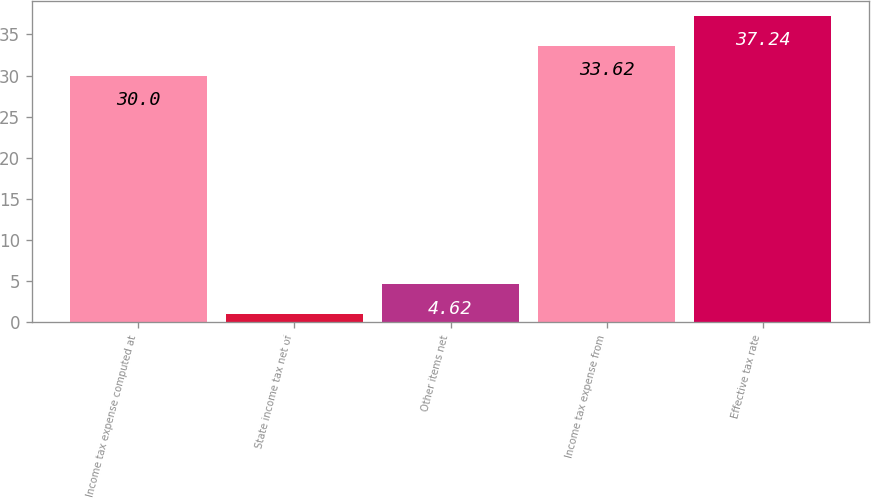Convert chart to OTSL. <chart><loc_0><loc_0><loc_500><loc_500><bar_chart><fcel>Income tax expense computed at<fcel>State income tax net of<fcel>Other items net<fcel>Income tax expense from<fcel>Effective tax rate<nl><fcel>30<fcel>1<fcel>4.62<fcel>33.62<fcel>37.24<nl></chart> 